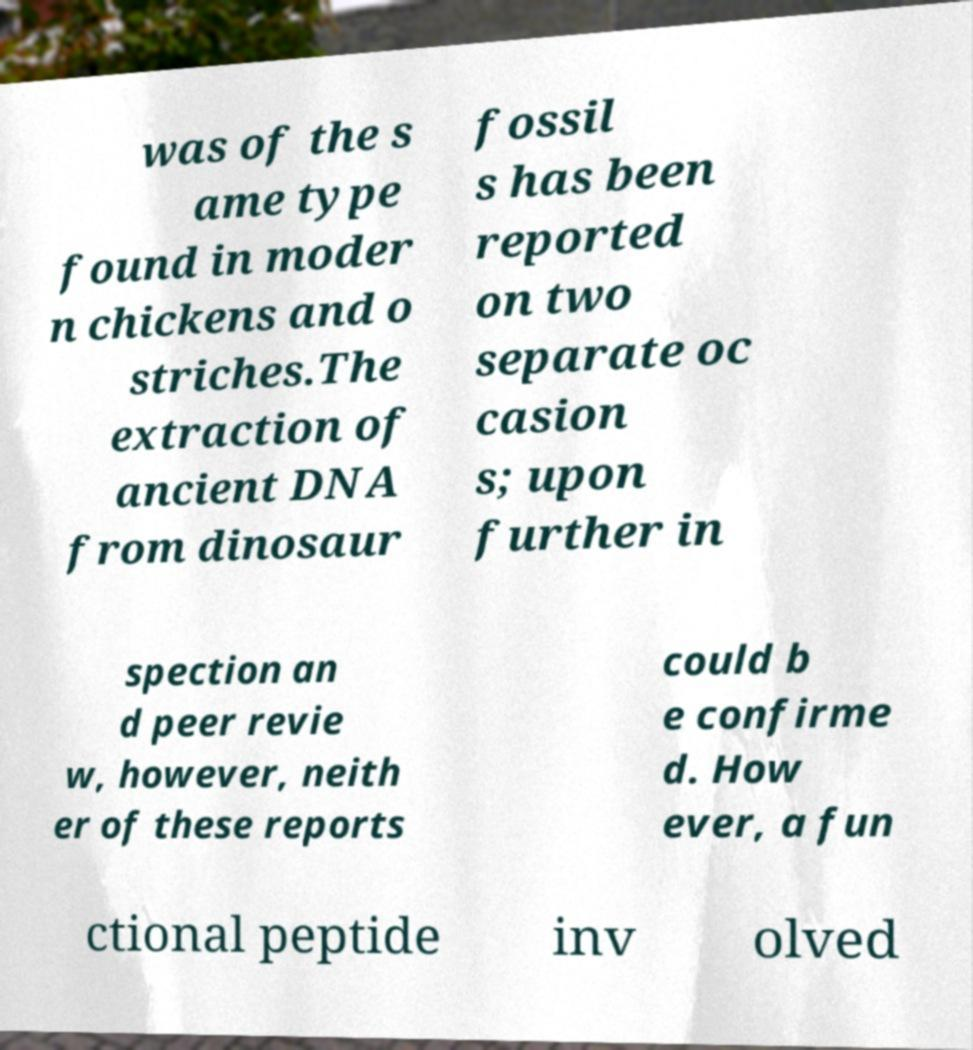Please identify and transcribe the text found in this image. was of the s ame type found in moder n chickens and o striches.The extraction of ancient DNA from dinosaur fossil s has been reported on two separate oc casion s; upon further in spection an d peer revie w, however, neith er of these reports could b e confirme d. How ever, a fun ctional peptide inv olved 